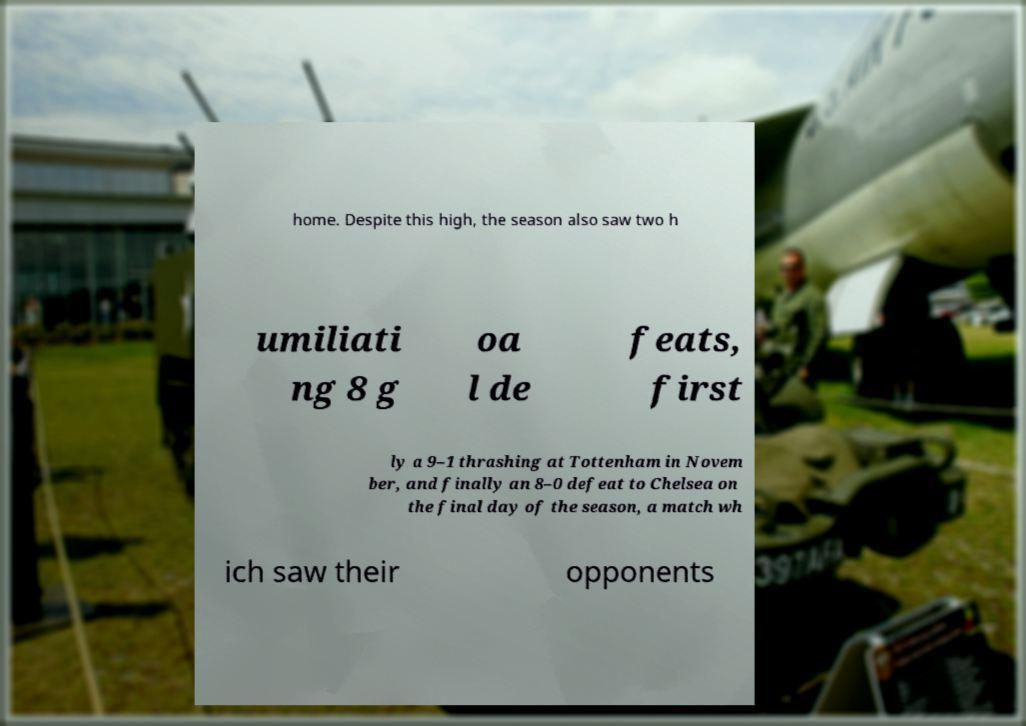Can you read and provide the text displayed in the image?This photo seems to have some interesting text. Can you extract and type it out for me? home. Despite this high, the season also saw two h umiliati ng 8 g oa l de feats, first ly a 9–1 thrashing at Tottenham in Novem ber, and finally an 8–0 defeat to Chelsea on the final day of the season, a match wh ich saw their opponents 